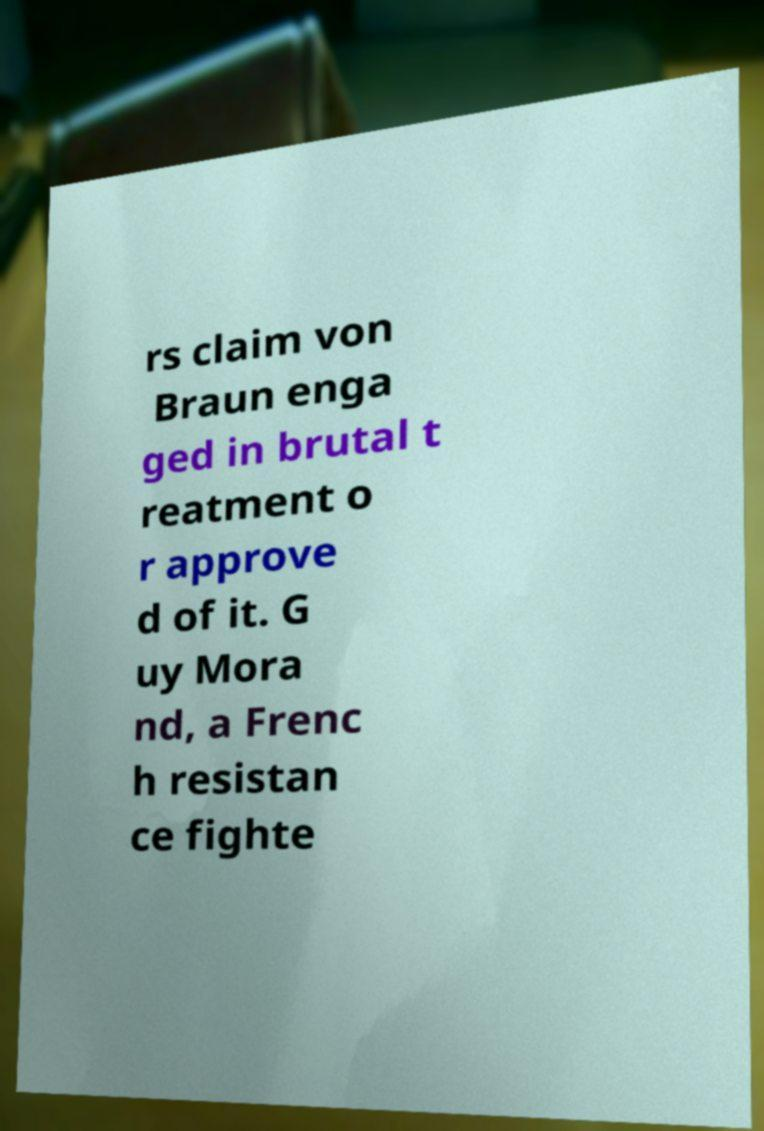Could you extract and type out the text from this image? rs claim von Braun enga ged in brutal t reatment o r approve d of it. G uy Mora nd, a Frenc h resistan ce fighte 